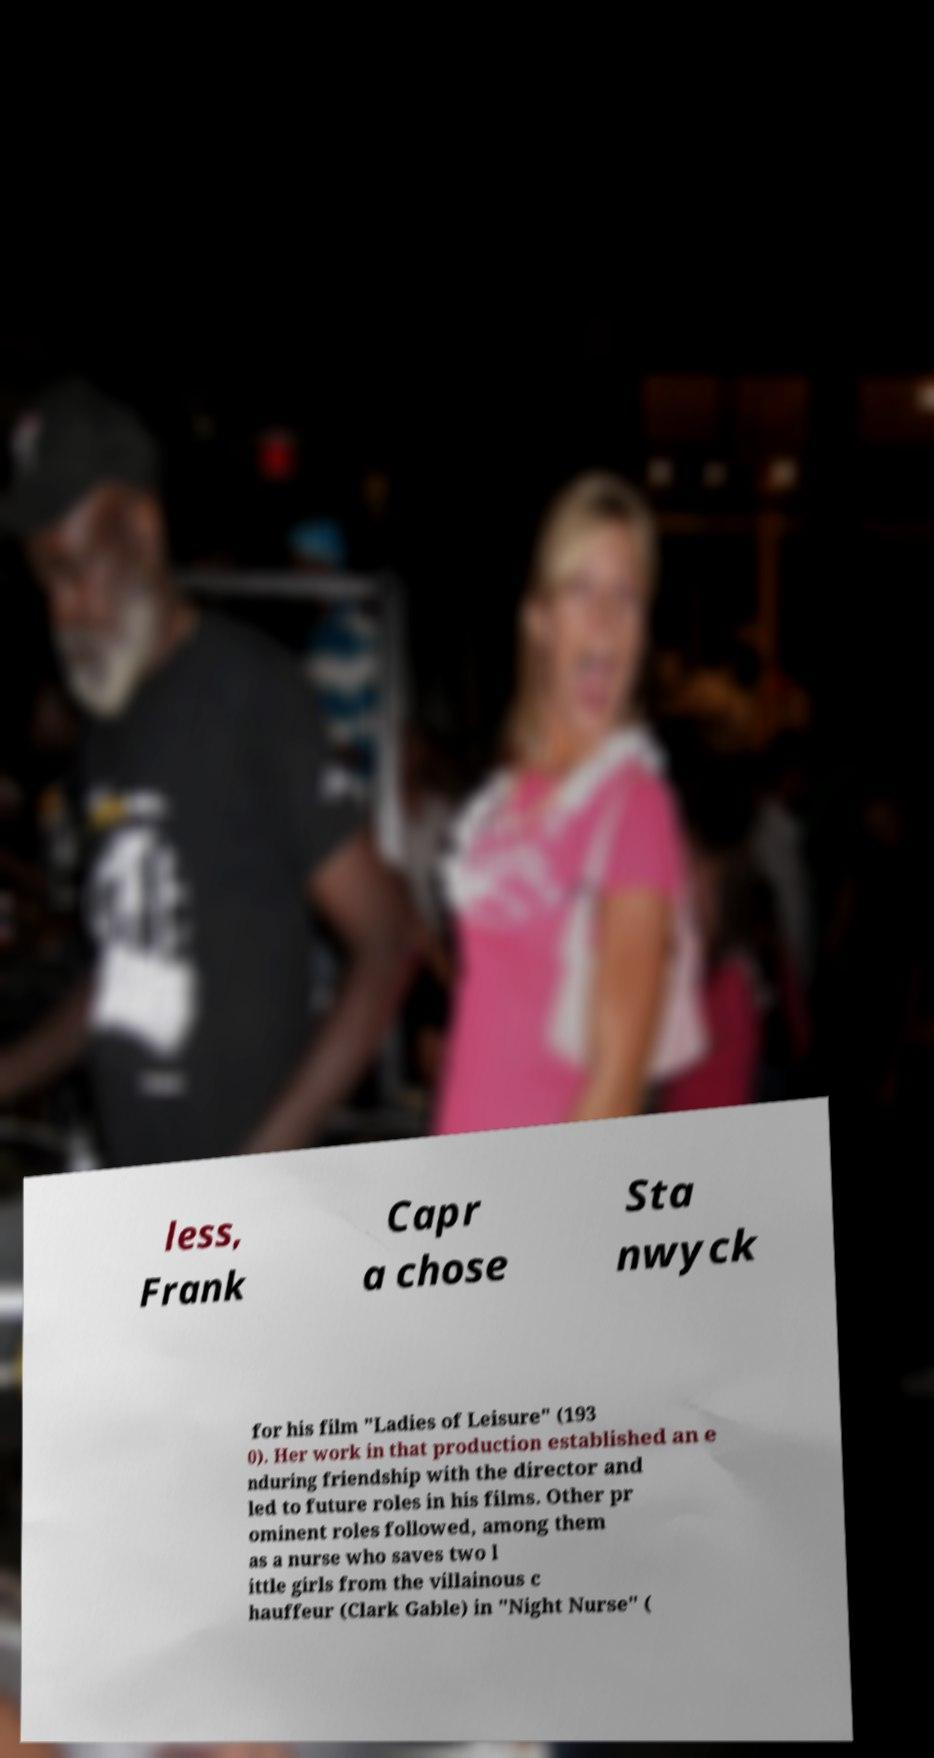Could you assist in decoding the text presented in this image and type it out clearly? less, Frank Capr a chose Sta nwyck for his film "Ladies of Leisure" (193 0). Her work in that production established an e nduring friendship with the director and led to future roles in his films. Other pr ominent roles followed, among them as a nurse who saves two l ittle girls from the villainous c hauffeur (Clark Gable) in "Night Nurse" ( 